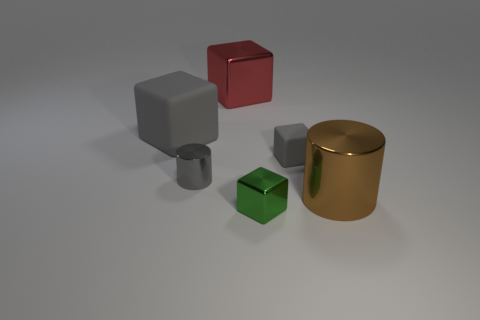Subtract all tiny gray rubber cubes. How many cubes are left? 3 Subtract all green cubes. How many cubes are left? 3 Add 1 shiny blocks. How many objects exist? 7 Subtract 1 gray cylinders. How many objects are left? 5 Subtract all cubes. How many objects are left? 2 Subtract 3 cubes. How many cubes are left? 1 Subtract all blue blocks. Subtract all blue balls. How many blocks are left? 4 Subtract all yellow cylinders. How many red cubes are left? 1 Subtract all big metallic cubes. Subtract all large red things. How many objects are left? 4 Add 6 small gray matte blocks. How many small gray matte blocks are left? 7 